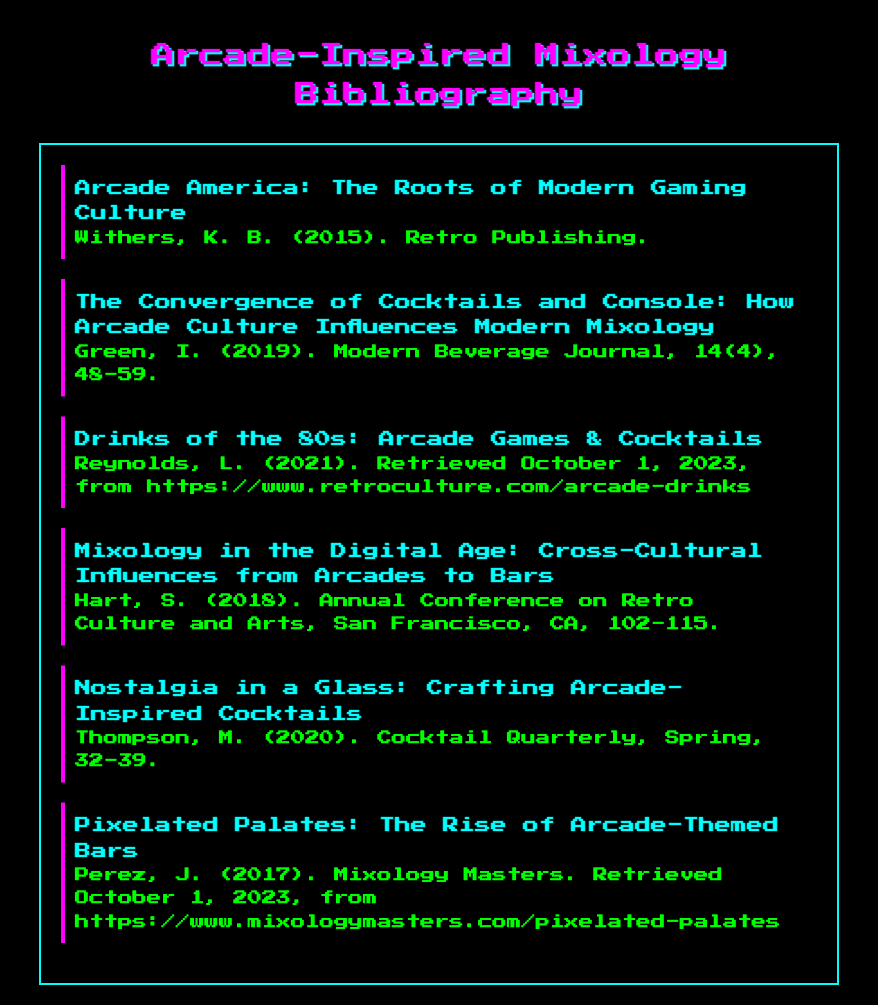What is the title of the first entry? The first entry's title is explicitly listed in the document as "Arcade America: The Roots of Modern Gaming Culture."
Answer: Arcade America: The Roots of Modern Gaming Culture Who is the author of the second entry? The author of the second entry is mentioned directly as "Green, I." in the bibliographic entry.
Answer: Green, I In what year was "Nostalgia in a Glass: Crafting Arcade-Inspired Cocktails" published? The year of publication is provided in the document as "2020" within the bibliographic entry.
Answer: 2020 What journal features the article by Hart, S.? The document specifies that Hart's article was presented at the "Annual Conference on Retro Culture and Arts."
Answer: Annual Conference on Retro Culture and Arts How many entries are there in this bibliography? The document lists a total of six distinct bibliographic entries on arcade-inspired mixology.
Answer: Six What is the theme of the third entry? The third entry primarily covers the connection between "Drinks of the 80s" and arcade culture in mixology, as indicated in the title.
Answer: Arcade games & Cocktails What online source is referenced for additional information in the fifth entry? The specific online source noted in the fifth entry is "https://www.mixologymasters.com/pixelated-palates."
Answer: https://www.mixologymasters.com/pixelated-palates Which entry discusses the cross-cultural influences of mixology? The entry discussing cross-cultural influences is clearly indicated by the title "Mixology in the Digital Age: Cross-Cultural Influences from Arcades to Bars."
Answer: Mixology in the Digital Age: Cross-Cultural Influences from Arcades to Bars 